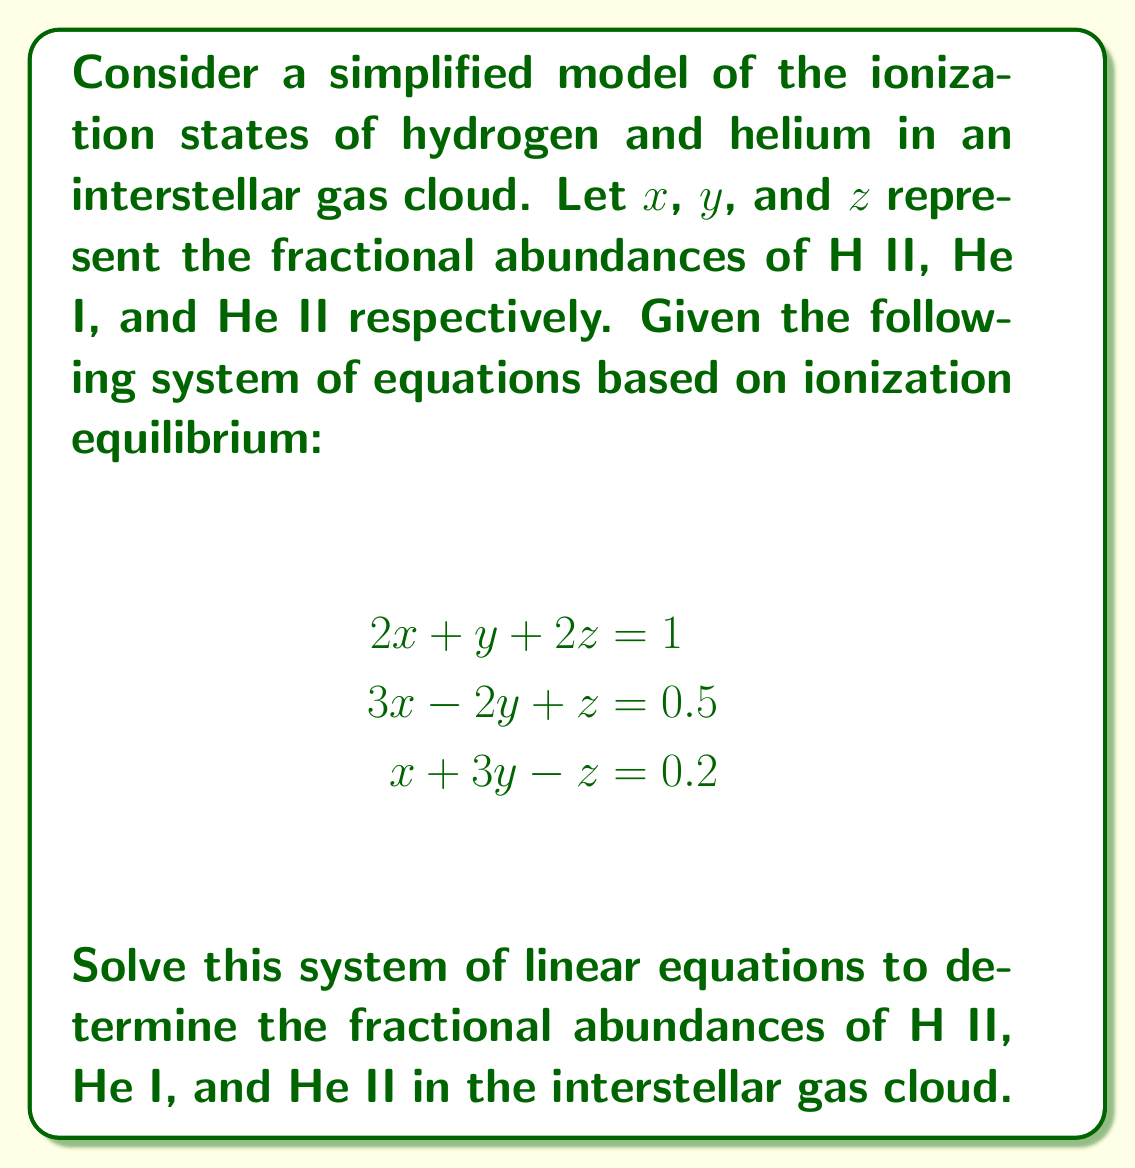Give your solution to this math problem. To solve this system of linear equations, we'll use the Gaussian elimination method:

1) First, let's write the augmented matrix for this system:

   $$\begin{bmatrix}
   2 & 1 & 2 & | & 1 \\
   3 & -2 & 1 & | & 0.5 \\
   1 & 3 & -1 & | & 0.2
   \end{bmatrix}$$

2) We'll use the first row as our pivot. Subtract 1.5 times the first row from the second row:

   $$\begin{bmatrix}
   2 & 1 & 2 & | & 1 \\
   0 & -3.5 & -2 & | & -1 \\
   1 & 3 & -1 & | & 0.2
   \end{bmatrix}$$

3) Now, subtract 0.5 times the first row from the third row:

   $$\begin{bmatrix}
   2 & 1 & 2 & | & 1 \\
   0 & -3.5 & -2 & | & -1 \\
   0 & 2.5 & -2 & | & -0.3
   \end{bmatrix}$$

4) Use the second row as the new pivot. Add $\frac{5}{7}$ times the second row to the third row:

   $$\begin{bmatrix}
   2 & 1 & 2 & | & 1 \\
   0 & -3.5 & -2 & | & -1 \\
   0 & 0 & -\frac{16}{7} & | & -\frac{13}{7}
   \end{bmatrix}$$

5) Now we have an upper triangular matrix. We can solve for $z$ from the third row:

   $-\frac{16}{7}z = -\frac{13}{7}$
   $z = \frac{13}{16} = 0.8125$

6) Substitute this value into the second row to solve for $y$:

   $-3.5y - 2(0.8125) = -1$
   $-3.5y = 0.625$
   $y = -\frac{5}{28} = -0.1786$

7) Finally, substitute these values into the first row to solve for $x$:

   $2x + (-0.1786) + 2(0.8125) = 1$
   $2x = -0.4464$
   $x = -0.2232$

Therefore, the solution is $x = -0.2232$, $y = -0.1786$, and $z = 0.8125$.
Answer: The fractional abundances are:
H II (x): -0.2232
He I (y): -0.1786
He II (z): 0.8125 